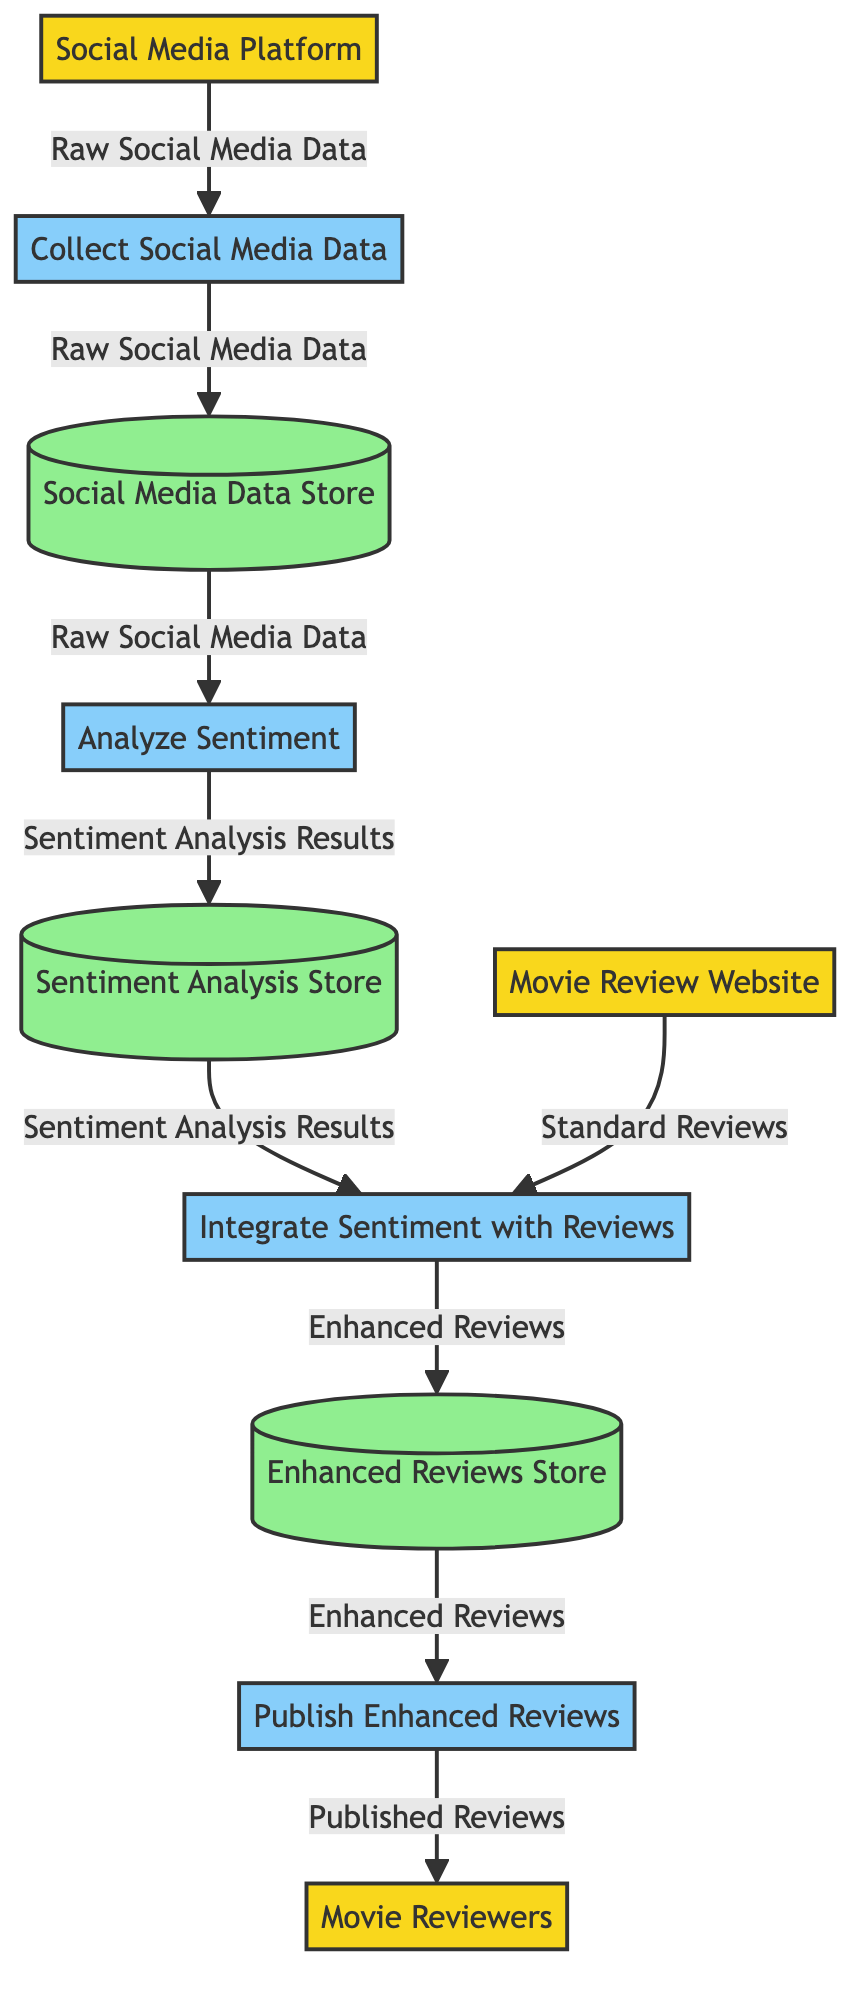What is the first process in the diagram? The first process indicated in the diagram is "Collect Social Media Data," which is the initial step that receives data from the Social Media Platform.
Answer: Collect Social Media Data How many external entities are present in the diagram? The diagram shows three external entities: Social Media Platform, Movie Review Website, and Movie Reviewers. Counting them gives a total of three external entities.
Answer: Three What data flow is produced by the "Analyze Sentiment" process? The "Analyze Sentiment" process produces "Sentiment Analysis Results," which is indicated as the output of that process in the diagram.
Answer: Sentiment Analysis Results Which data store is used to collect social media data? The social media data is collected in the "Social Media Data Store," as shown in the data flow from "Collect Social Media Data" to this specific store.
Answer: Social Media Data Store From which external entity does the "Integrate Sentiment with Reviews" process receive data? The "Integrate Sentiment with Reviews" process receives data from the "Movie Review Website," which is defined as one of the external entities in the diagram.
Answer: Movie Review Website What is the final output of the diagram? The final output of the diagram is "Published Reviews," which is the result of the "Publish Enhanced Reviews" process and the last step in the flow.
Answer: Published Reviews How many processes are involved in integrating social media sentiment into movie reviews? The diagram features four processes: "Collect Social Media Data," "Analyze Sentiment," "Integrate Sentiment with Reviews," and "Publish Enhanced Reviews." Adding these together results in four processes.
Answer: Four What data is stored in the Enhanced Reviews Store? The Enhanced Reviews Store contains "Enhanced Reviews," as indicated by the output flow from the "Integrate Sentiment with Reviews" process to this data store.
Answer: Enhanced Reviews What is the direct data flow from the Social Media Platform? The direct data flow from the Social Media Platform is "Raw Social Media Data," which feeds into the "Collect Social Media Data" process.
Answer: Raw Social Media Data Which process utilizes data from the Sentiment Analysis Store? The process that utilizes data from the Sentiment Analysis Store is "Integrate Sentiment with Reviews," as indicated by the flow from the Sentiment Analysis Store into this process.
Answer: Integrate Sentiment with Reviews 